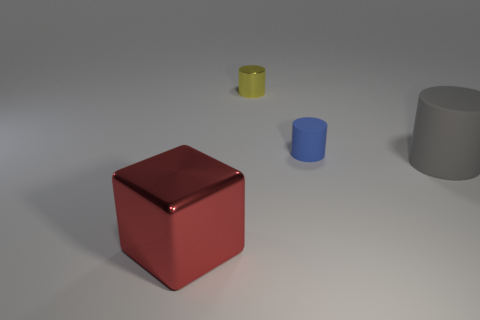What material is the object in front of the large thing to the right of the big red block? metal 